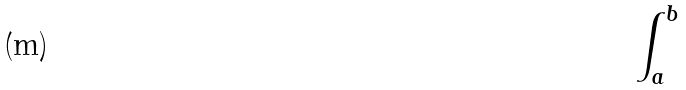<formula> <loc_0><loc_0><loc_500><loc_500>\int _ { a } ^ { b }</formula> 